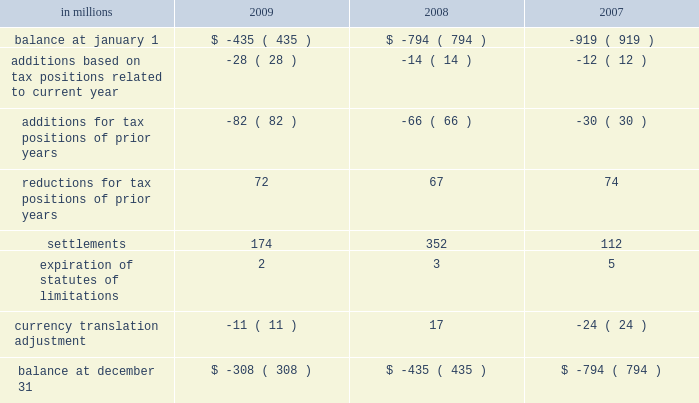Deferred tax assets and liabilities are recorded in the accompanying consolidated balance sheet under the captions deferred income tax assets , deferred charges and other assets , other accrued liabilities and deferred income taxes .
The decrease in 2009 in deferred tax assets principally relates to the tax impact of changes in recorded qualified pension liabilities , minimum tax credit utilization and an increase in the valuation allowance .
The decrease in deferred income tax liabilities principally relates to less tax depreciation taken on the company 2019s assets purchased in 2009 .
The valuation allowance for deferred tax assets as of december 31 , 2008 was $ 72 million .
The net change in the total valuation allowance for the year ended december 31 , 2009 , was an increase of $ 274 million .
The increase of $ 274 million consists primarily of : ( 1 ) $ 211 million related to the company 2019s french operations , including a valuation allowance of $ 55 million against net deferred tax assets from current year operations and $ 156 million recorded in the second quarter of 2009 for the establishment of a valuation allowance against previously recorded deferred tax assets , ( 2 ) $ 10 million for net deferred tax assets arising from the company 2019s united king- dom current year operations , and ( 3 ) $ 47 million related to a reduction of previously recorded u.s .
State deferred tax assets , including $ 15 million recorded in the fourth quarter of 2009 for louisiana recycling credits .
The effect on the company 2019s effec- tive tax rate of the aforementioned $ 211 million and $ 10 million is included in the line item 201ctax rate and permanent differences on non-u.s .
Earnings . 201d international paper adopted the provisions of new guidance under asc 740 , 201cincome taxes , 201d on jan- uary 1 , 2007 related to uncertain tax positions .
As a result of the implementation of this new guidance , the company recorded a charge to the beginning balance of retained earnings of $ 94 million , which was accounted for as a reduction to the january 1 , 2007 balance of retained earnings .
A reconciliation of the beginning and ending amount of unrecognized tax benefits for the year ending december 31 , 2009 and 2008 is as follows : in millions 2009 2008 2007 .
Included in the balance at december 31 , 2009 and 2008 are $ 56 million and $ 9 million , respectively , for tax positions for which the ultimate benefits are highly certain , but for which there is uncertainty about the timing of such benefits .
However , except for the possible effect of any penalties , any dis- allowance that would change the timing of these benefits would not affect the annual effective tax rate , but would accelerate the payment of cash to the taxing authority to an earlier period .
The company accrues interest on unrecognized tax benefits as a component of interest expense .
Penal- ties , if incurred , are recognized as a component of income tax expense .
The company had approx- imately $ 95 million and $ 74 million accrued for the payment of estimated interest and penalties asso- ciated with unrecognized tax benefits at december 31 , 2009 and 2008 , respectively .
The major jurisdictions where the company files income tax returns are the united states , brazil , france , poland and russia .
Generally , tax years 2002 through 2009 remain open and subject to examina- tion by the relevant tax authorities .
The company is typically engaged in various tax examinations at any given time , both in the united states and overseas .
Currently , the company is engaged in discussions with the u.s .
Internal revenue service regarding the examination of tax years 2006 and 2007 .
As a result of these discussions , other pending tax audit settle- ments , and the expiration of statutes of limitation , the company currently estimates that the amount of unrecognized tax benefits could be reduced by up to $ 125 million during the next twelve months .
During 2009 , unrecognized tax benefits decreased by $ 127 million .
While the company believes that it is adequately accrued for possible audit adjustments , the final resolution of these examinations cannot be determined at this time and could result in final settlements that differ from current estimates .
The company 2019s 2009 income tax provision of $ 469 million included $ 279 million related to special items and other charges , consisting of a $ 534 million tax benefit related to restructuring and other charges , a $ 650 million tax expense for the alternative fuel mixture credit , and $ 163 million of tax-related adjustments including a $ 156 million tax expense to establish a valuation allowance for net operating loss carryforwards in france , a $ 26 million tax benefit for the effective settlement of federal tax audits , a $ 15 million tax expense to establish a valuation allow- ance for louisiana recycling credits , and $ 18 million of other income tax adjustments .
Excluding the impact of special items , the tax provision was .
What was the percentage change in the deffered tax asset balance in 2009 from 2008? 
Computations: (274 / 72)
Answer: 3.80556. 